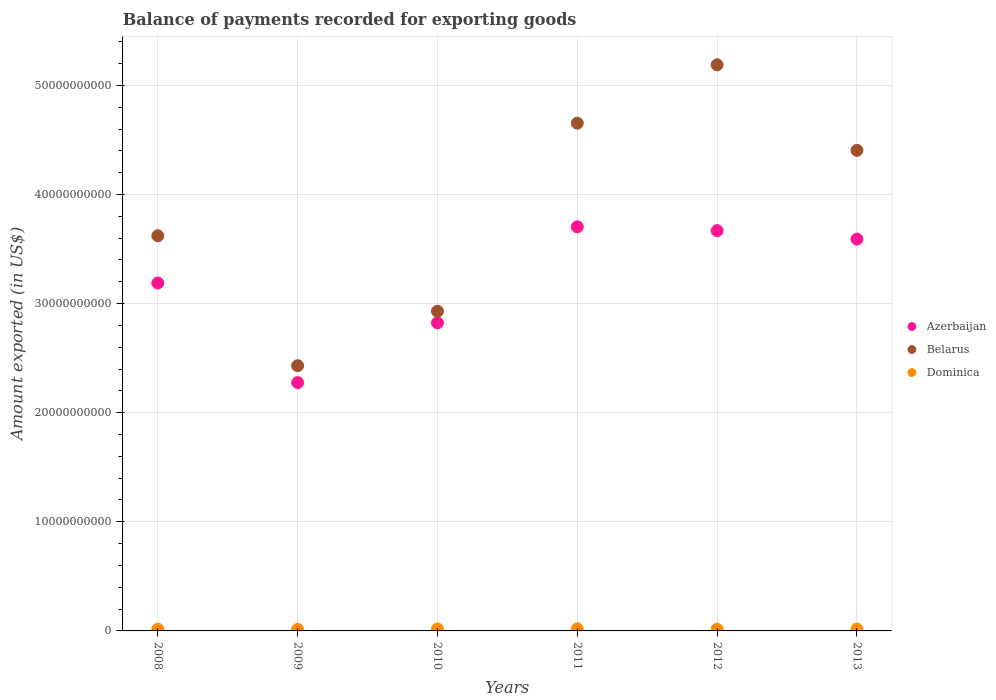How many different coloured dotlines are there?
Your answer should be compact. 3. What is the amount exported in Belarus in 2011?
Make the answer very short. 4.65e+1. Across all years, what is the maximum amount exported in Azerbaijan?
Give a very brief answer. 3.70e+1. Across all years, what is the minimum amount exported in Dominica?
Your response must be concise. 1.48e+08. In which year was the amount exported in Azerbaijan maximum?
Provide a succinct answer. 2011. In which year was the amount exported in Dominica minimum?
Offer a terse response. 2009. What is the total amount exported in Dominica in the graph?
Your answer should be very brief. 1.00e+09. What is the difference between the amount exported in Dominica in 2008 and that in 2013?
Provide a succinct answer. -1.29e+07. What is the difference between the amount exported in Belarus in 2009 and the amount exported in Dominica in 2008?
Your answer should be compact. 2.42e+1. What is the average amount exported in Azerbaijan per year?
Ensure brevity in your answer.  3.21e+1. In the year 2011, what is the difference between the amount exported in Azerbaijan and amount exported in Belarus?
Offer a terse response. -9.50e+09. What is the ratio of the amount exported in Belarus in 2010 to that in 2013?
Your answer should be compact. 0.67. What is the difference between the highest and the second highest amount exported in Belarus?
Your response must be concise. 5.35e+09. What is the difference between the highest and the lowest amount exported in Dominica?
Provide a succinct answer. 4.30e+07. In how many years, is the amount exported in Dominica greater than the average amount exported in Dominica taken over all years?
Provide a succinct answer. 3. Does the amount exported in Belarus monotonically increase over the years?
Your response must be concise. No. Is the amount exported in Belarus strictly less than the amount exported in Dominica over the years?
Your answer should be very brief. No. Are the values on the major ticks of Y-axis written in scientific E-notation?
Provide a succinct answer. No. Does the graph contain any zero values?
Keep it short and to the point. No. What is the title of the graph?
Ensure brevity in your answer.  Balance of payments recorded for exporting goods. What is the label or title of the X-axis?
Provide a succinct answer. Years. What is the label or title of the Y-axis?
Provide a succinct answer. Amount exported (in US$). What is the Amount exported (in US$) of Azerbaijan in 2008?
Ensure brevity in your answer.  3.19e+1. What is the Amount exported (in US$) in Belarus in 2008?
Provide a short and direct response. 3.62e+1. What is the Amount exported (in US$) in Dominica in 2008?
Your answer should be very brief. 1.57e+08. What is the Amount exported (in US$) of Azerbaijan in 2009?
Give a very brief answer. 2.28e+1. What is the Amount exported (in US$) of Belarus in 2009?
Provide a succinct answer. 2.43e+1. What is the Amount exported (in US$) in Dominica in 2009?
Offer a very short reply. 1.48e+08. What is the Amount exported (in US$) of Azerbaijan in 2010?
Keep it short and to the point. 2.82e+1. What is the Amount exported (in US$) in Belarus in 2010?
Provide a short and direct response. 2.93e+1. What is the Amount exported (in US$) in Dominica in 2010?
Offer a terse response. 1.74e+08. What is the Amount exported (in US$) of Azerbaijan in 2011?
Keep it short and to the point. 3.70e+1. What is the Amount exported (in US$) of Belarus in 2011?
Give a very brief answer. 4.65e+1. What is the Amount exported (in US$) in Dominica in 2011?
Offer a terse response. 1.91e+08. What is the Amount exported (in US$) in Azerbaijan in 2012?
Keep it short and to the point. 3.67e+1. What is the Amount exported (in US$) in Belarus in 2012?
Make the answer very short. 5.19e+1. What is the Amount exported (in US$) of Dominica in 2012?
Offer a very short reply. 1.60e+08. What is the Amount exported (in US$) in Azerbaijan in 2013?
Your response must be concise. 3.59e+1. What is the Amount exported (in US$) of Belarus in 2013?
Keep it short and to the point. 4.40e+1. What is the Amount exported (in US$) in Dominica in 2013?
Keep it short and to the point. 1.70e+08. Across all years, what is the maximum Amount exported (in US$) of Azerbaijan?
Your response must be concise. 3.70e+1. Across all years, what is the maximum Amount exported (in US$) of Belarus?
Provide a succinct answer. 5.19e+1. Across all years, what is the maximum Amount exported (in US$) of Dominica?
Your response must be concise. 1.91e+08. Across all years, what is the minimum Amount exported (in US$) of Azerbaijan?
Your answer should be very brief. 2.28e+1. Across all years, what is the minimum Amount exported (in US$) in Belarus?
Make the answer very short. 2.43e+1. Across all years, what is the minimum Amount exported (in US$) of Dominica?
Offer a terse response. 1.48e+08. What is the total Amount exported (in US$) of Azerbaijan in the graph?
Ensure brevity in your answer.  1.93e+11. What is the total Amount exported (in US$) of Belarus in the graph?
Provide a short and direct response. 2.32e+11. What is the total Amount exported (in US$) in Dominica in the graph?
Your answer should be compact. 1.00e+09. What is the difference between the Amount exported (in US$) in Azerbaijan in 2008 and that in 2009?
Make the answer very short. 9.13e+09. What is the difference between the Amount exported (in US$) in Belarus in 2008 and that in 2009?
Ensure brevity in your answer.  1.19e+1. What is the difference between the Amount exported (in US$) in Dominica in 2008 and that in 2009?
Make the answer very short. 8.78e+06. What is the difference between the Amount exported (in US$) of Azerbaijan in 2008 and that in 2010?
Offer a very short reply. 3.65e+09. What is the difference between the Amount exported (in US$) of Belarus in 2008 and that in 2010?
Offer a very short reply. 6.92e+09. What is the difference between the Amount exported (in US$) of Dominica in 2008 and that in 2010?
Keep it short and to the point. -1.73e+07. What is the difference between the Amount exported (in US$) of Azerbaijan in 2008 and that in 2011?
Offer a terse response. -5.15e+09. What is the difference between the Amount exported (in US$) in Belarus in 2008 and that in 2011?
Your response must be concise. -1.03e+1. What is the difference between the Amount exported (in US$) of Dominica in 2008 and that in 2011?
Keep it short and to the point. -3.42e+07. What is the difference between the Amount exported (in US$) in Azerbaijan in 2008 and that in 2012?
Provide a short and direct response. -4.80e+09. What is the difference between the Amount exported (in US$) in Belarus in 2008 and that in 2012?
Offer a terse response. -1.57e+1. What is the difference between the Amount exported (in US$) of Dominica in 2008 and that in 2012?
Keep it short and to the point. -3.53e+06. What is the difference between the Amount exported (in US$) of Azerbaijan in 2008 and that in 2013?
Make the answer very short. -4.02e+09. What is the difference between the Amount exported (in US$) of Belarus in 2008 and that in 2013?
Provide a succinct answer. -7.83e+09. What is the difference between the Amount exported (in US$) in Dominica in 2008 and that in 2013?
Your answer should be very brief. -1.29e+07. What is the difference between the Amount exported (in US$) of Azerbaijan in 2009 and that in 2010?
Ensure brevity in your answer.  -5.48e+09. What is the difference between the Amount exported (in US$) in Belarus in 2009 and that in 2010?
Make the answer very short. -4.99e+09. What is the difference between the Amount exported (in US$) of Dominica in 2009 and that in 2010?
Ensure brevity in your answer.  -2.61e+07. What is the difference between the Amount exported (in US$) of Azerbaijan in 2009 and that in 2011?
Your response must be concise. -1.43e+1. What is the difference between the Amount exported (in US$) of Belarus in 2009 and that in 2011?
Your answer should be compact. -2.22e+1. What is the difference between the Amount exported (in US$) of Dominica in 2009 and that in 2011?
Give a very brief answer. -4.30e+07. What is the difference between the Amount exported (in US$) in Azerbaijan in 2009 and that in 2012?
Make the answer very short. -1.39e+1. What is the difference between the Amount exported (in US$) of Belarus in 2009 and that in 2012?
Keep it short and to the point. -2.76e+1. What is the difference between the Amount exported (in US$) of Dominica in 2009 and that in 2012?
Your response must be concise. -1.23e+07. What is the difference between the Amount exported (in US$) of Azerbaijan in 2009 and that in 2013?
Give a very brief answer. -1.32e+1. What is the difference between the Amount exported (in US$) of Belarus in 2009 and that in 2013?
Your answer should be compact. -1.97e+1. What is the difference between the Amount exported (in US$) of Dominica in 2009 and that in 2013?
Ensure brevity in your answer.  -2.17e+07. What is the difference between the Amount exported (in US$) in Azerbaijan in 2010 and that in 2011?
Make the answer very short. -8.80e+09. What is the difference between the Amount exported (in US$) in Belarus in 2010 and that in 2011?
Your answer should be compact. -1.72e+1. What is the difference between the Amount exported (in US$) in Dominica in 2010 and that in 2011?
Offer a very short reply. -1.69e+07. What is the difference between the Amount exported (in US$) of Azerbaijan in 2010 and that in 2012?
Keep it short and to the point. -8.45e+09. What is the difference between the Amount exported (in US$) in Belarus in 2010 and that in 2012?
Provide a short and direct response. -2.26e+1. What is the difference between the Amount exported (in US$) in Dominica in 2010 and that in 2012?
Offer a very short reply. 1.38e+07. What is the difference between the Amount exported (in US$) of Azerbaijan in 2010 and that in 2013?
Provide a succinct answer. -7.68e+09. What is the difference between the Amount exported (in US$) of Belarus in 2010 and that in 2013?
Provide a succinct answer. -1.47e+1. What is the difference between the Amount exported (in US$) of Dominica in 2010 and that in 2013?
Keep it short and to the point. 4.42e+06. What is the difference between the Amount exported (in US$) of Azerbaijan in 2011 and that in 2012?
Keep it short and to the point. 3.53e+08. What is the difference between the Amount exported (in US$) in Belarus in 2011 and that in 2012?
Make the answer very short. -5.35e+09. What is the difference between the Amount exported (in US$) of Dominica in 2011 and that in 2012?
Provide a succinct answer. 3.07e+07. What is the difference between the Amount exported (in US$) in Azerbaijan in 2011 and that in 2013?
Offer a very short reply. 1.13e+09. What is the difference between the Amount exported (in US$) of Belarus in 2011 and that in 2013?
Offer a terse response. 2.49e+09. What is the difference between the Amount exported (in US$) of Dominica in 2011 and that in 2013?
Your answer should be very brief. 2.13e+07. What is the difference between the Amount exported (in US$) of Azerbaijan in 2012 and that in 2013?
Make the answer very short. 7.74e+08. What is the difference between the Amount exported (in US$) in Belarus in 2012 and that in 2013?
Ensure brevity in your answer.  7.84e+09. What is the difference between the Amount exported (in US$) of Dominica in 2012 and that in 2013?
Offer a terse response. -9.38e+06. What is the difference between the Amount exported (in US$) of Azerbaijan in 2008 and the Amount exported (in US$) of Belarus in 2009?
Your response must be concise. 7.58e+09. What is the difference between the Amount exported (in US$) in Azerbaijan in 2008 and the Amount exported (in US$) in Dominica in 2009?
Offer a terse response. 3.17e+1. What is the difference between the Amount exported (in US$) of Belarus in 2008 and the Amount exported (in US$) of Dominica in 2009?
Give a very brief answer. 3.61e+1. What is the difference between the Amount exported (in US$) in Azerbaijan in 2008 and the Amount exported (in US$) in Belarus in 2010?
Your response must be concise. 2.59e+09. What is the difference between the Amount exported (in US$) of Azerbaijan in 2008 and the Amount exported (in US$) of Dominica in 2010?
Offer a very short reply. 3.17e+1. What is the difference between the Amount exported (in US$) in Belarus in 2008 and the Amount exported (in US$) in Dominica in 2010?
Give a very brief answer. 3.60e+1. What is the difference between the Amount exported (in US$) in Azerbaijan in 2008 and the Amount exported (in US$) in Belarus in 2011?
Provide a short and direct response. -1.46e+1. What is the difference between the Amount exported (in US$) in Azerbaijan in 2008 and the Amount exported (in US$) in Dominica in 2011?
Ensure brevity in your answer.  3.17e+1. What is the difference between the Amount exported (in US$) of Belarus in 2008 and the Amount exported (in US$) of Dominica in 2011?
Your answer should be very brief. 3.60e+1. What is the difference between the Amount exported (in US$) in Azerbaijan in 2008 and the Amount exported (in US$) in Belarus in 2012?
Your answer should be compact. -2.00e+1. What is the difference between the Amount exported (in US$) of Azerbaijan in 2008 and the Amount exported (in US$) of Dominica in 2012?
Offer a terse response. 3.17e+1. What is the difference between the Amount exported (in US$) in Belarus in 2008 and the Amount exported (in US$) in Dominica in 2012?
Keep it short and to the point. 3.61e+1. What is the difference between the Amount exported (in US$) of Azerbaijan in 2008 and the Amount exported (in US$) of Belarus in 2013?
Give a very brief answer. -1.22e+1. What is the difference between the Amount exported (in US$) of Azerbaijan in 2008 and the Amount exported (in US$) of Dominica in 2013?
Provide a short and direct response. 3.17e+1. What is the difference between the Amount exported (in US$) in Belarus in 2008 and the Amount exported (in US$) in Dominica in 2013?
Provide a short and direct response. 3.60e+1. What is the difference between the Amount exported (in US$) in Azerbaijan in 2009 and the Amount exported (in US$) in Belarus in 2010?
Your response must be concise. -6.54e+09. What is the difference between the Amount exported (in US$) of Azerbaijan in 2009 and the Amount exported (in US$) of Dominica in 2010?
Your response must be concise. 2.26e+1. What is the difference between the Amount exported (in US$) of Belarus in 2009 and the Amount exported (in US$) of Dominica in 2010?
Your answer should be compact. 2.41e+1. What is the difference between the Amount exported (in US$) of Azerbaijan in 2009 and the Amount exported (in US$) of Belarus in 2011?
Your answer should be very brief. -2.38e+1. What is the difference between the Amount exported (in US$) in Azerbaijan in 2009 and the Amount exported (in US$) in Dominica in 2011?
Your response must be concise. 2.26e+1. What is the difference between the Amount exported (in US$) of Belarus in 2009 and the Amount exported (in US$) of Dominica in 2011?
Keep it short and to the point. 2.41e+1. What is the difference between the Amount exported (in US$) of Azerbaijan in 2009 and the Amount exported (in US$) of Belarus in 2012?
Your answer should be very brief. -2.91e+1. What is the difference between the Amount exported (in US$) in Azerbaijan in 2009 and the Amount exported (in US$) in Dominica in 2012?
Offer a very short reply. 2.26e+1. What is the difference between the Amount exported (in US$) in Belarus in 2009 and the Amount exported (in US$) in Dominica in 2012?
Your response must be concise. 2.42e+1. What is the difference between the Amount exported (in US$) of Azerbaijan in 2009 and the Amount exported (in US$) of Belarus in 2013?
Provide a short and direct response. -2.13e+1. What is the difference between the Amount exported (in US$) in Azerbaijan in 2009 and the Amount exported (in US$) in Dominica in 2013?
Your answer should be compact. 2.26e+1. What is the difference between the Amount exported (in US$) in Belarus in 2009 and the Amount exported (in US$) in Dominica in 2013?
Offer a very short reply. 2.41e+1. What is the difference between the Amount exported (in US$) of Azerbaijan in 2010 and the Amount exported (in US$) of Belarus in 2011?
Your answer should be very brief. -1.83e+1. What is the difference between the Amount exported (in US$) of Azerbaijan in 2010 and the Amount exported (in US$) of Dominica in 2011?
Your response must be concise. 2.80e+1. What is the difference between the Amount exported (in US$) in Belarus in 2010 and the Amount exported (in US$) in Dominica in 2011?
Your answer should be compact. 2.91e+1. What is the difference between the Amount exported (in US$) in Azerbaijan in 2010 and the Amount exported (in US$) in Belarus in 2012?
Make the answer very short. -2.37e+1. What is the difference between the Amount exported (in US$) in Azerbaijan in 2010 and the Amount exported (in US$) in Dominica in 2012?
Give a very brief answer. 2.81e+1. What is the difference between the Amount exported (in US$) in Belarus in 2010 and the Amount exported (in US$) in Dominica in 2012?
Provide a short and direct response. 2.91e+1. What is the difference between the Amount exported (in US$) of Azerbaijan in 2010 and the Amount exported (in US$) of Belarus in 2013?
Your response must be concise. -1.58e+1. What is the difference between the Amount exported (in US$) in Azerbaijan in 2010 and the Amount exported (in US$) in Dominica in 2013?
Your answer should be very brief. 2.81e+1. What is the difference between the Amount exported (in US$) in Belarus in 2010 and the Amount exported (in US$) in Dominica in 2013?
Keep it short and to the point. 2.91e+1. What is the difference between the Amount exported (in US$) in Azerbaijan in 2011 and the Amount exported (in US$) in Belarus in 2012?
Keep it short and to the point. -1.48e+1. What is the difference between the Amount exported (in US$) of Azerbaijan in 2011 and the Amount exported (in US$) of Dominica in 2012?
Offer a very short reply. 3.69e+1. What is the difference between the Amount exported (in US$) in Belarus in 2011 and the Amount exported (in US$) in Dominica in 2012?
Make the answer very short. 4.64e+1. What is the difference between the Amount exported (in US$) of Azerbaijan in 2011 and the Amount exported (in US$) of Belarus in 2013?
Offer a terse response. -7.01e+09. What is the difference between the Amount exported (in US$) of Azerbaijan in 2011 and the Amount exported (in US$) of Dominica in 2013?
Provide a short and direct response. 3.69e+1. What is the difference between the Amount exported (in US$) in Belarus in 2011 and the Amount exported (in US$) in Dominica in 2013?
Offer a very short reply. 4.64e+1. What is the difference between the Amount exported (in US$) of Azerbaijan in 2012 and the Amount exported (in US$) of Belarus in 2013?
Your answer should be very brief. -7.36e+09. What is the difference between the Amount exported (in US$) in Azerbaijan in 2012 and the Amount exported (in US$) in Dominica in 2013?
Give a very brief answer. 3.65e+1. What is the difference between the Amount exported (in US$) of Belarus in 2012 and the Amount exported (in US$) of Dominica in 2013?
Provide a short and direct response. 5.17e+1. What is the average Amount exported (in US$) of Azerbaijan per year?
Your answer should be compact. 3.21e+1. What is the average Amount exported (in US$) in Belarus per year?
Offer a very short reply. 3.87e+1. What is the average Amount exported (in US$) of Dominica per year?
Your answer should be very brief. 1.67e+08. In the year 2008, what is the difference between the Amount exported (in US$) in Azerbaijan and Amount exported (in US$) in Belarus?
Provide a succinct answer. -4.33e+09. In the year 2008, what is the difference between the Amount exported (in US$) of Azerbaijan and Amount exported (in US$) of Dominica?
Ensure brevity in your answer.  3.17e+1. In the year 2008, what is the difference between the Amount exported (in US$) in Belarus and Amount exported (in US$) in Dominica?
Your answer should be compact. 3.61e+1. In the year 2009, what is the difference between the Amount exported (in US$) in Azerbaijan and Amount exported (in US$) in Belarus?
Offer a very short reply. -1.55e+09. In the year 2009, what is the difference between the Amount exported (in US$) in Azerbaijan and Amount exported (in US$) in Dominica?
Ensure brevity in your answer.  2.26e+1. In the year 2009, what is the difference between the Amount exported (in US$) of Belarus and Amount exported (in US$) of Dominica?
Ensure brevity in your answer.  2.42e+1. In the year 2010, what is the difference between the Amount exported (in US$) of Azerbaijan and Amount exported (in US$) of Belarus?
Offer a terse response. -1.07e+09. In the year 2010, what is the difference between the Amount exported (in US$) in Azerbaijan and Amount exported (in US$) in Dominica?
Make the answer very short. 2.81e+1. In the year 2010, what is the difference between the Amount exported (in US$) in Belarus and Amount exported (in US$) in Dominica?
Provide a short and direct response. 2.91e+1. In the year 2011, what is the difference between the Amount exported (in US$) in Azerbaijan and Amount exported (in US$) in Belarus?
Your response must be concise. -9.50e+09. In the year 2011, what is the difference between the Amount exported (in US$) in Azerbaijan and Amount exported (in US$) in Dominica?
Offer a very short reply. 3.68e+1. In the year 2011, what is the difference between the Amount exported (in US$) of Belarus and Amount exported (in US$) of Dominica?
Make the answer very short. 4.63e+1. In the year 2012, what is the difference between the Amount exported (in US$) of Azerbaijan and Amount exported (in US$) of Belarus?
Offer a terse response. -1.52e+1. In the year 2012, what is the difference between the Amount exported (in US$) of Azerbaijan and Amount exported (in US$) of Dominica?
Your response must be concise. 3.65e+1. In the year 2012, what is the difference between the Amount exported (in US$) in Belarus and Amount exported (in US$) in Dominica?
Your answer should be very brief. 5.17e+1. In the year 2013, what is the difference between the Amount exported (in US$) of Azerbaijan and Amount exported (in US$) of Belarus?
Offer a very short reply. -8.13e+09. In the year 2013, what is the difference between the Amount exported (in US$) of Azerbaijan and Amount exported (in US$) of Dominica?
Offer a very short reply. 3.57e+1. In the year 2013, what is the difference between the Amount exported (in US$) of Belarus and Amount exported (in US$) of Dominica?
Offer a very short reply. 4.39e+1. What is the ratio of the Amount exported (in US$) in Azerbaijan in 2008 to that in 2009?
Offer a terse response. 1.4. What is the ratio of the Amount exported (in US$) of Belarus in 2008 to that in 2009?
Make the answer very short. 1.49. What is the ratio of the Amount exported (in US$) of Dominica in 2008 to that in 2009?
Your answer should be very brief. 1.06. What is the ratio of the Amount exported (in US$) in Azerbaijan in 2008 to that in 2010?
Give a very brief answer. 1.13. What is the ratio of the Amount exported (in US$) in Belarus in 2008 to that in 2010?
Your answer should be very brief. 1.24. What is the ratio of the Amount exported (in US$) in Dominica in 2008 to that in 2010?
Your answer should be compact. 0.9. What is the ratio of the Amount exported (in US$) of Azerbaijan in 2008 to that in 2011?
Keep it short and to the point. 0.86. What is the ratio of the Amount exported (in US$) of Belarus in 2008 to that in 2011?
Offer a terse response. 0.78. What is the ratio of the Amount exported (in US$) of Dominica in 2008 to that in 2011?
Ensure brevity in your answer.  0.82. What is the ratio of the Amount exported (in US$) in Azerbaijan in 2008 to that in 2012?
Ensure brevity in your answer.  0.87. What is the ratio of the Amount exported (in US$) of Belarus in 2008 to that in 2012?
Provide a short and direct response. 0.7. What is the ratio of the Amount exported (in US$) of Dominica in 2008 to that in 2012?
Offer a terse response. 0.98. What is the ratio of the Amount exported (in US$) of Azerbaijan in 2008 to that in 2013?
Provide a short and direct response. 0.89. What is the ratio of the Amount exported (in US$) in Belarus in 2008 to that in 2013?
Provide a short and direct response. 0.82. What is the ratio of the Amount exported (in US$) in Dominica in 2008 to that in 2013?
Keep it short and to the point. 0.92. What is the ratio of the Amount exported (in US$) in Azerbaijan in 2009 to that in 2010?
Give a very brief answer. 0.81. What is the ratio of the Amount exported (in US$) in Belarus in 2009 to that in 2010?
Give a very brief answer. 0.83. What is the ratio of the Amount exported (in US$) of Dominica in 2009 to that in 2010?
Your answer should be compact. 0.85. What is the ratio of the Amount exported (in US$) in Azerbaijan in 2009 to that in 2011?
Make the answer very short. 0.61. What is the ratio of the Amount exported (in US$) in Belarus in 2009 to that in 2011?
Give a very brief answer. 0.52. What is the ratio of the Amount exported (in US$) of Dominica in 2009 to that in 2011?
Give a very brief answer. 0.77. What is the ratio of the Amount exported (in US$) of Azerbaijan in 2009 to that in 2012?
Offer a terse response. 0.62. What is the ratio of the Amount exported (in US$) of Belarus in 2009 to that in 2012?
Give a very brief answer. 0.47. What is the ratio of the Amount exported (in US$) of Azerbaijan in 2009 to that in 2013?
Your answer should be compact. 0.63. What is the ratio of the Amount exported (in US$) of Belarus in 2009 to that in 2013?
Give a very brief answer. 0.55. What is the ratio of the Amount exported (in US$) in Dominica in 2009 to that in 2013?
Offer a terse response. 0.87. What is the ratio of the Amount exported (in US$) of Azerbaijan in 2010 to that in 2011?
Ensure brevity in your answer.  0.76. What is the ratio of the Amount exported (in US$) in Belarus in 2010 to that in 2011?
Your answer should be very brief. 0.63. What is the ratio of the Amount exported (in US$) in Dominica in 2010 to that in 2011?
Provide a succinct answer. 0.91. What is the ratio of the Amount exported (in US$) of Azerbaijan in 2010 to that in 2012?
Provide a succinct answer. 0.77. What is the ratio of the Amount exported (in US$) in Belarus in 2010 to that in 2012?
Give a very brief answer. 0.56. What is the ratio of the Amount exported (in US$) of Dominica in 2010 to that in 2012?
Ensure brevity in your answer.  1.09. What is the ratio of the Amount exported (in US$) of Azerbaijan in 2010 to that in 2013?
Keep it short and to the point. 0.79. What is the ratio of the Amount exported (in US$) of Belarus in 2010 to that in 2013?
Ensure brevity in your answer.  0.67. What is the ratio of the Amount exported (in US$) in Azerbaijan in 2011 to that in 2012?
Your answer should be very brief. 1.01. What is the ratio of the Amount exported (in US$) in Belarus in 2011 to that in 2012?
Keep it short and to the point. 0.9. What is the ratio of the Amount exported (in US$) of Dominica in 2011 to that in 2012?
Make the answer very short. 1.19. What is the ratio of the Amount exported (in US$) in Azerbaijan in 2011 to that in 2013?
Keep it short and to the point. 1.03. What is the ratio of the Amount exported (in US$) in Belarus in 2011 to that in 2013?
Your response must be concise. 1.06. What is the ratio of the Amount exported (in US$) of Dominica in 2011 to that in 2013?
Ensure brevity in your answer.  1.13. What is the ratio of the Amount exported (in US$) in Azerbaijan in 2012 to that in 2013?
Your response must be concise. 1.02. What is the ratio of the Amount exported (in US$) in Belarus in 2012 to that in 2013?
Give a very brief answer. 1.18. What is the ratio of the Amount exported (in US$) in Dominica in 2012 to that in 2013?
Make the answer very short. 0.94. What is the difference between the highest and the second highest Amount exported (in US$) of Azerbaijan?
Provide a short and direct response. 3.53e+08. What is the difference between the highest and the second highest Amount exported (in US$) in Belarus?
Provide a short and direct response. 5.35e+09. What is the difference between the highest and the second highest Amount exported (in US$) in Dominica?
Provide a short and direct response. 1.69e+07. What is the difference between the highest and the lowest Amount exported (in US$) in Azerbaijan?
Give a very brief answer. 1.43e+1. What is the difference between the highest and the lowest Amount exported (in US$) in Belarus?
Your answer should be compact. 2.76e+1. What is the difference between the highest and the lowest Amount exported (in US$) in Dominica?
Provide a short and direct response. 4.30e+07. 